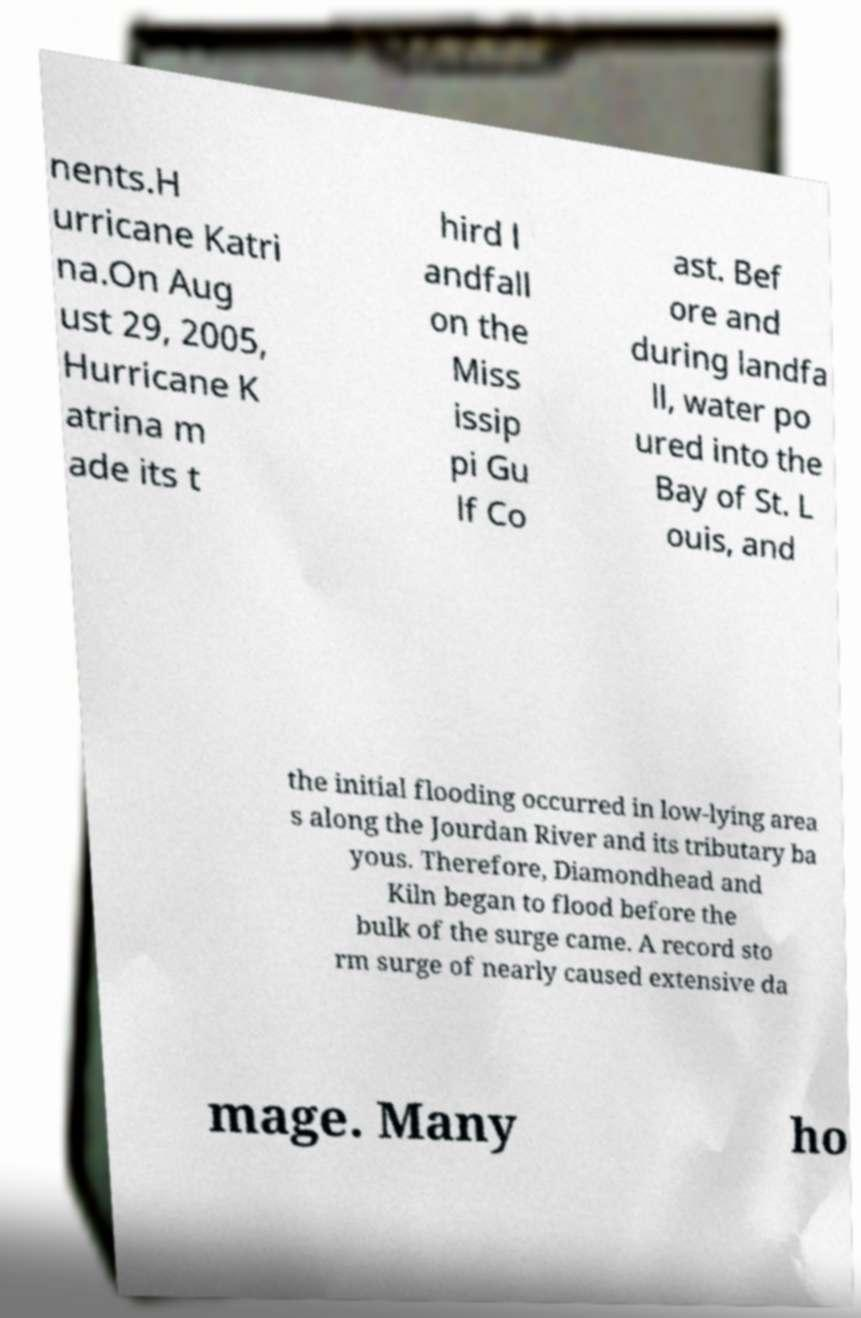Please read and relay the text visible in this image. What does it say? nents.H urricane Katri na.On Aug ust 29, 2005, Hurricane K atrina m ade its t hird l andfall on the Miss issip pi Gu lf Co ast. Bef ore and during landfa ll, water po ured into the Bay of St. L ouis, and the initial flooding occurred in low-lying area s along the Jourdan River and its tributary ba yous. Therefore, Diamondhead and Kiln began to flood before the bulk of the surge came. A record sto rm surge of nearly caused extensive da mage. Many ho 